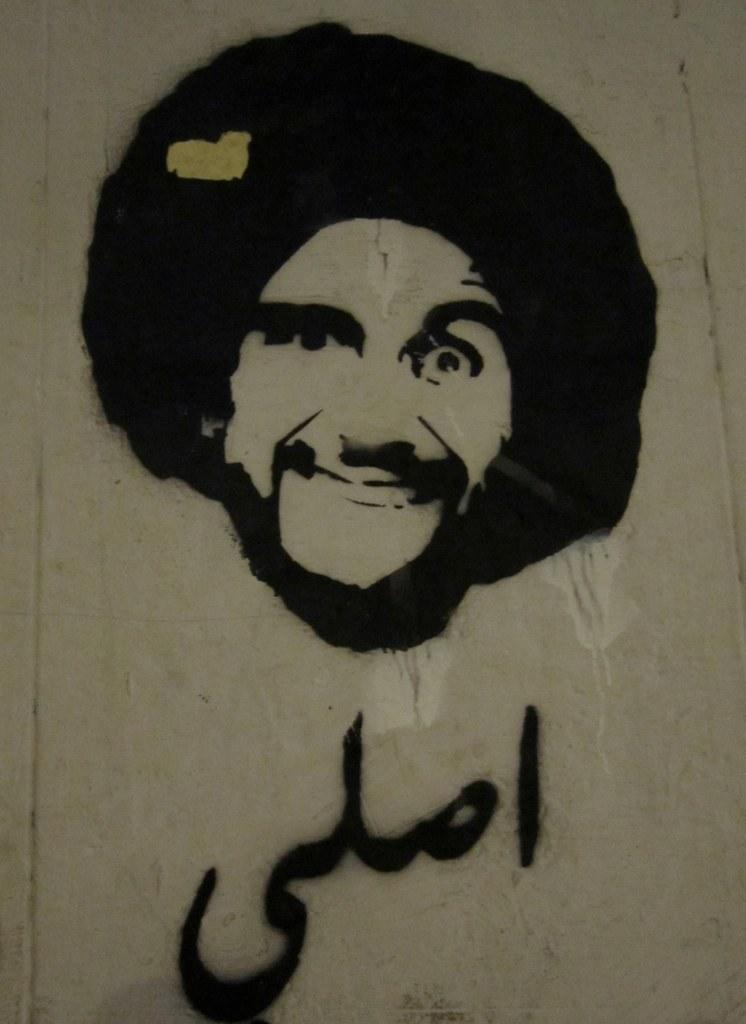What is the main subject of the image? There is a painting in the image. What is depicted in the painting? The painting is of a person. Where is the painting located? The painting is on a wall. What type of feast is being prepared in the painting? There is no feast or any indication of food preparation in the painting; it is a portrait of a person. How many dimes can be seen on the wall next to the painting? There are no dimes visible in the image; it only features the painting on the wall. 